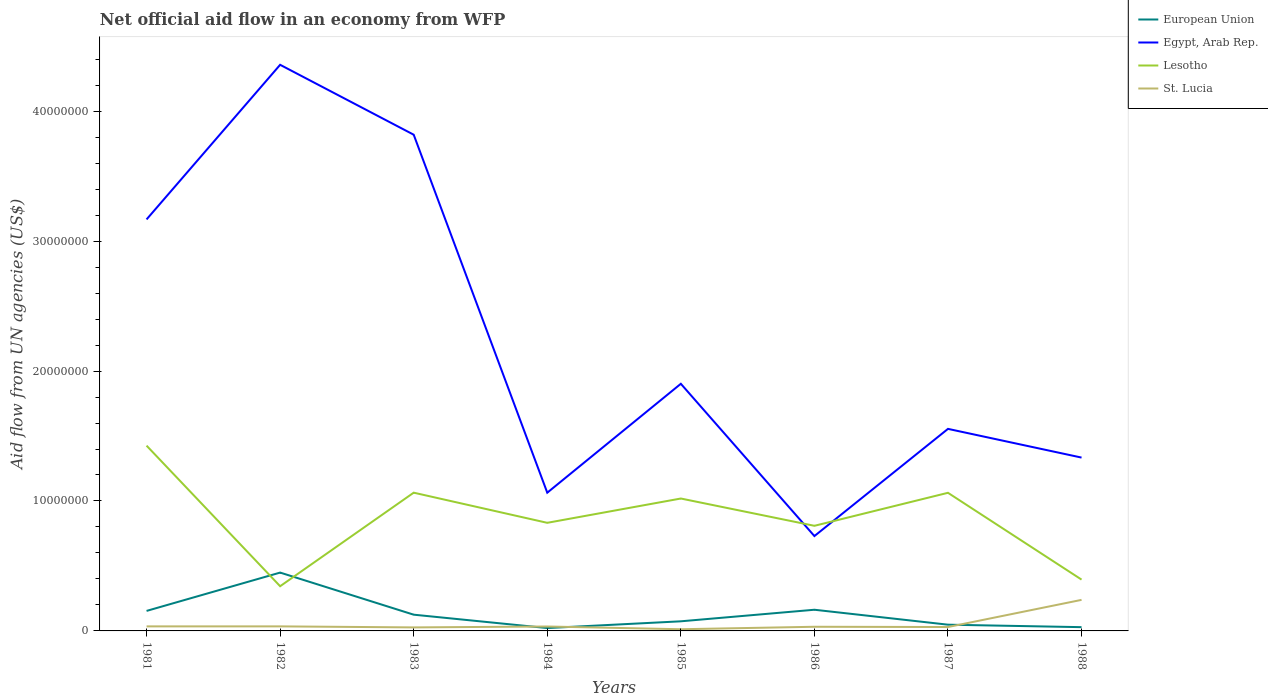How many different coloured lines are there?
Ensure brevity in your answer.  4. Is the number of lines equal to the number of legend labels?
Make the answer very short. Yes. In which year was the net official aid flow in Egypt, Arab Rep. maximum?
Your response must be concise. 1986. What is the total net official aid flow in European Union in the graph?
Give a very brief answer. -8.90e+05. What is the difference between the highest and the second highest net official aid flow in Lesotho?
Provide a short and direct response. 1.08e+07. How many lines are there?
Your response must be concise. 4. How many years are there in the graph?
Ensure brevity in your answer.  8. Are the values on the major ticks of Y-axis written in scientific E-notation?
Ensure brevity in your answer.  No. Does the graph contain any zero values?
Give a very brief answer. No. How many legend labels are there?
Keep it short and to the point. 4. How are the legend labels stacked?
Your response must be concise. Vertical. What is the title of the graph?
Your response must be concise. Net official aid flow in an economy from WFP. What is the label or title of the X-axis?
Provide a succinct answer. Years. What is the label or title of the Y-axis?
Your answer should be very brief. Aid flow from UN agencies (US$). What is the Aid flow from UN agencies (US$) of European Union in 1981?
Keep it short and to the point. 1.54e+06. What is the Aid flow from UN agencies (US$) of Egypt, Arab Rep. in 1981?
Your answer should be compact. 3.17e+07. What is the Aid flow from UN agencies (US$) in Lesotho in 1981?
Offer a terse response. 1.43e+07. What is the Aid flow from UN agencies (US$) of St. Lucia in 1981?
Keep it short and to the point. 3.50e+05. What is the Aid flow from UN agencies (US$) of European Union in 1982?
Your answer should be very brief. 4.49e+06. What is the Aid flow from UN agencies (US$) of Egypt, Arab Rep. in 1982?
Your response must be concise. 4.36e+07. What is the Aid flow from UN agencies (US$) of Lesotho in 1982?
Your answer should be compact. 3.44e+06. What is the Aid flow from UN agencies (US$) in St. Lucia in 1982?
Your response must be concise. 3.50e+05. What is the Aid flow from UN agencies (US$) of European Union in 1983?
Ensure brevity in your answer.  1.25e+06. What is the Aid flow from UN agencies (US$) in Egypt, Arab Rep. in 1983?
Ensure brevity in your answer.  3.82e+07. What is the Aid flow from UN agencies (US$) in Lesotho in 1983?
Your answer should be compact. 1.06e+07. What is the Aid flow from UN agencies (US$) in St. Lucia in 1983?
Give a very brief answer. 2.70e+05. What is the Aid flow from UN agencies (US$) of Egypt, Arab Rep. in 1984?
Provide a succinct answer. 1.06e+07. What is the Aid flow from UN agencies (US$) of Lesotho in 1984?
Keep it short and to the point. 8.32e+06. What is the Aid flow from UN agencies (US$) of St. Lucia in 1984?
Offer a very short reply. 3.40e+05. What is the Aid flow from UN agencies (US$) of European Union in 1985?
Your answer should be very brief. 7.40e+05. What is the Aid flow from UN agencies (US$) in Egypt, Arab Rep. in 1985?
Your response must be concise. 1.90e+07. What is the Aid flow from UN agencies (US$) of Lesotho in 1985?
Keep it short and to the point. 1.02e+07. What is the Aid flow from UN agencies (US$) of St. Lucia in 1985?
Provide a short and direct response. 1.30e+05. What is the Aid flow from UN agencies (US$) in European Union in 1986?
Provide a succinct answer. 1.63e+06. What is the Aid flow from UN agencies (US$) in Egypt, Arab Rep. in 1986?
Provide a short and direct response. 7.30e+06. What is the Aid flow from UN agencies (US$) of Lesotho in 1986?
Give a very brief answer. 8.09e+06. What is the Aid flow from UN agencies (US$) in Egypt, Arab Rep. in 1987?
Offer a terse response. 1.56e+07. What is the Aid flow from UN agencies (US$) of Lesotho in 1987?
Offer a very short reply. 1.06e+07. What is the Aid flow from UN agencies (US$) in European Union in 1988?
Your answer should be compact. 2.90e+05. What is the Aid flow from UN agencies (US$) in Egypt, Arab Rep. in 1988?
Offer a terse response. 1.33e+07. What is the Aid flow from UN agencies (US$) in Lesotho in 1988?
Provide a short and direct response. 3.95e+06. What is the Aid flow from UN agencies (US$) in St. Lucia in 1988?
Your response must be concise. 2.39e+06. Across all years, what is the maximum Aid flow from UN agencies (US$) in European Union?
Offer a very short reply. 4.49e+06. Across all years, what is the maximum Aid flow from UN agencies (US$) of Egypt, Arab Rep.?
Give a very brief answer. 4.36e+07. Across all years, what is the maximum Aid flow from UN agencies (US$) of Lesotho?
Provide a short and direct response. 1.43e+07. Across all years, what is the maximum Aid flow from UN agencies (US$) of St. Lucia?
Ensure brevity in your answer.  2.39e+06. Across all years, what is the minimum Aid flow from UN agencies (US$) in Egypt, Arab Rep.?
Your answer should be very brief. 7.30e+06. Across all years, what is the minimum Aid flow from UN agencies (US$) in Lesotho?
Your answer should be compact. 3.44e+06. Across all years, what is the minimum Aid flow from UN agencies (US$) in St. Lucia?
Provide a short and direct response. 1.30e+05. What is the total Aid flow from UN agencies (US$) of European Union in the graph?
Give a very brief answer. 1.06e+07. What is the total Aid flow from UN agencies (US$) in Egypt, Arab Rep. in the graph?
Make the answer very short. 1.79e+08. What is the total Aid flow from UN agencies (US$) of Lesotho in the graph?
Provide a short and direct response. 6.95e+07. What is the total Aid flow from UN agencies (US$) in St. Lucia in the graph?
Ensure brevity in your answer.  4.45e+06. What is the difference between the Aid flow from UN agencies (US$) in European Union in 1981 and that in 1982?
Offer a terse response. -2.95e+06. What is the difference between the Aid flow from UN agencies (US$) of Egypt, Arab Rep. in 1981 and that in 1982?
Make the answer very short. -1.19e+07. What is the difference between the Aid flow from UN agencies (US$) in Lesotho in 1981 and that in 1982?
Ensure brevity in your answer.  1.08e+07. What is the difference between the Aid flow from UN agencies (US$) of European Union in 1981 and that in 1983?
Your answer should be compact. 2.90e+05. What is the difference between the Aid flow from UN agencies (US$) of Egypt, Arab Rep. in 1981 and that in 1983?
Offer a terse response. -6.52e+06. What is the difference between the Aid flow from UN agencies (US$) of Lesotho in 1981 and that in 1983?
Your answer should be very brief. 3.62e+06. What is the difference between the Aid flow from UN agencies (US$) of European Union in 1981 and that in 1984?
Offer a terse response. 1.32e+06. What is the difference between the Aid flow from UN agencies (US$) in Egypt, Arab Rep. in 1981 and that in 1984?
Ensure brevity in your answer.  2.10e+07. What is the difference between the Aid flow from UN agencies (US$) in Lesotho in 1981 and that in 1984?
Ensure brevity in your answer.  5.94e+06. What is the difference between the Aid flow from UN agencies (US$) in European Union in 1981 and that in 1985?
Give a very brief answer. 8.00e+05. What is the difference between the Aid flow from UN agencies (US$) of Egypt, Arab Rep. in 1981 and that in 1985?
Keep it short and to the point. 1.26e+07. What is the difference between the Aid flow from UN agencies (US$) in Lesotho in 1981 and that in 1985?
Offer a very short reply. 4.07e+06. What is the difference between the Aid flow from UN agencies (US$) of St. Lucia in 1981 and that in 1985?
Ensure brevity in your answer.  2.20e+05. What is the difference between the Aid flow from UN agencies (US$) of Egypt, Arab Rep. in 1981 and that in 1986?
Keep it short and to the point. 2.44e+07. What is the difference between the Aid flow from UN agencies (US$) in Lesotho in 1981 and that in 1986?
Your answer should be compact. 6.17e+06. What is the difference between the Aid flow from UN agencies (US$) of St. Lucia in 1981 and that in 1986?
Your response must be concise. 3.00e+04. What is the difference between the Aid flow from UN agencies (US$) in European Union in 1981 and that in 1987?
Provide a succinct answer. 1.06e+06. What is the difference between the Aid flow from UN agencies (US$) of Egypt, Arab Rep. in 1981 and that in 1987?
Provide a short and direct response. 1.61e+07. What is the difference between the Aid flow from UN agencies (US$) in Lesotho in 1981 and that in 1987?
Your answer should be very brief. 3.63e+06. What is the difference between the Aid flow from UN agencies (US$) in St. Lucia in 1981 and that in 1987?
Your answer should be very brief. 5.00e+04. What is the difference between the Aid flow from UN agencies (US$) of European Union in 1981 and that in 1988?
Offer a terse response. 1.25e+06. What is the difference between the Aid flow from UN agencies (US$) in Egypt, Arab Rep. in 1981 and that in 1988?
Ensure brevity in your answer.  1.83e+07. What is the difference between the Aid flow from UN agencies (US$) in Lesotho in 1981 and that in 1988?
Offer a terse response. 1.03e+07. What is the difference between the Aid flow from UN agencies (US$) of St. Lucia in 1981 and that in 1988?
Offer a terse response. -2.04e+06. What is the difference between the Aid flow from UN agencies (US$) of European Union in 1982 and that in 1983?
Your answer should be very brief. 3.24e+06. What is the difference between the Aid flow from UN agencies (US$) of Egypt, Arab Rep. in 1982 and that in 1983?
Offer a very short reply. 5.38e+06. What is the difference between the Aid flow from UN agencies (US$) in Lesotho in 1982 and that in 1983?
Keep it short and to the point. -7.20e+06. What is the difference between the Aid flow from UN agencies (US$) of European Union in 1982 and that in 1984?
Your response must be concise. 4.27e+06. What is the difference between the Aid flow from UN agencies (US$) in Egypt, Arab Rep. in 1982 and that in 1984?
Your response must be concise. 3.29e+07. What is the difference between the Aid flow from UN agencies (US$) in Lesotho in 1982 and that in 1984?
Make the answer very short. -4.88e+06. What is the difference between the Aid flow from UN agencies (US$) in European Union in 1982 and that in 1985?
Give a very brief answer. 3.75e+06. What is the difference between the Aid flow from UN agencies (US$) in Egypt, Arab Rep. in 1982 and that in 1985?
Your answer should be very brief. 2.46e+07. What is the difference between the Aid flow from UN agencies (US$) of Lesotho in 1982 and that in 1985?
Your answer should be very brief. -6.75e+06. What is the difference between the Aid flow from UN agencies (US$) in European Union in 1982 and that in 1986?
Ensure brevity in your answer.  2.86e+06. What is the difference between the Aid flow from UN agencies (US$) of Egypt, Arab Rep. in 1982 and that in 1986?
Make the answer very short. 3.63e+07. What is the difference between the Aid flow from UN agencies (US$) of Lesotho in 1982 and that in 1986?
Ensure brevity in your answer.  -4.65e+06. What is the difference between the Aid flow from UN agencies (US$) in European Union in 1982 and that in 1987?
Make the answer very short. 4.01e+06. What is the difference between the Aid flow from UN agencies (US$) of Egypt, Arab Rep. in 1982 and that in 1987?
Give a very brief answer. 2.80e+07. What is the difference between the Aid flow from UN agencies (US$) in Lesotho in 1982 and that in 1987?
Give a very brief answer. -7.19e+06. What is the difference between the Aid flow from UN agencies (US$) in European Union in 1982 and that in 1988?
Offer a terse response. 4.20e+06. What is the difference between the Aid flow from UN agencies (US$) in Egypt, Arab Rep. in 1982 and that in 1988?
Provide a succinct answer. 3.02e+07. What is the difference between the Aid flow from UN agencies (US$) of Lesotho in 1982 and that in 1988?
Offer a terse response. -5.10e+05. What is the difference between the Aid flow from UN agencies (US$) of St. Lucia in 1982 and that in 1988?
Make the answer very short. -2.04e+06. What is the difference between the Aid flow from UN agencies (US$) in European Union in 1983 and that in 1984?
Ensure brevity in your answer.  1.03e+06. What is the difference between the Aid flow from UN agencies (US$) in Egypt, Arab Rep. in 1983 and that in 1984?
Ensure brevity in your answer.  2.76e+07. What is the difference between the Aid flow from UN agencies (US$) in Lesotho in 1983 and that in 1984?
Your answer should be very brief. 2.32e+06. What is the difference between the Aid flow from UN agencies (US$) of St. Lucia in 1983 and that in 1984?
Make the answer very short. -7.00e+04. What is the difference between the Aid flow from UN agencies (US$) of European Union in 1983 and that in 1985?
Provide a succinct answer. 5.10e+05. What is the difference between the Aid flow from UN agencies (US$) of Egypt, Arab Rep. in 1983 and that in 1985?
Provide a short and direct response. 1.92e+07. What is the difference between the Aid flow from UN agencies (US$) of European Union in 1983 and that in 1986?
Provide a succinct answer. -3.80e+05. What is the difference between the Aid flow from UN agencies (US$) of Egypt, Arab Rep. in 1983 and that in 1986?
Your answer should be very brief. 3.09e+07. What is the difference between the Aid flow from UN agencies (US$) of Lesotho in 1983 and that in 1986?
Provide a succinct answer. 2.55e+06. What is the difference between the Aid flow from UN agencies (US$) of St. Lucia in 1983 and that in 1986?
Make the answer very short. -5.00e+04. What is the difference between the Aid flow from UN agencies (US$) in European Union in 1983 and that in 1987?
Make the answer very short. 7.70e+05. What is the difference between the Aid flow from UN agencies (US$) of Egypt, Arab Rep. in 1983 and that in 1987?
Your answer should be very brief. 2.26e+07. What is the difference between the Aid flow from UN agencies (US$) in Lesotho in 1983 and that in 1987?
Your answer should be compact. 10000. What is the difference between the Aid flow from UN agencies (US$) in St. Lucia in 1983 and that in 1987?
Your answer should be compact. -3.00e+04. What is the difference between the Aid flow from UN agencies (US$) in European Union in 1983 and that in 1988?
Your answer should be very brief. 9.60e+05. What is the difference between the Aid flow from UN agencies (US$) of Egypt, Arab Rep. in 1983 and that in 1988?
Your answer should be compact. 2.48e+07. What is the difference between the Aid flow from UN agencies (US$) in Lesotho in 1983 and that in 1988?
Offer a very short reply. 6.69e+06. What is the difference between the Aid flow from UN agencies (US$) in St. Lucia in 1983 and that in 1988?
Offer a very short reply. -2.12e+06. What is the difference between the Aid flow from UN agencies (US$) of European Union in 1984 and that in 1985?
Your answer should be very brief. -5.20e+05. What is the difference between the Aid flow from UN agencies (US$) in Egypt, Arab Rep. in 1984 and that in 1985?
Provide a short and direct response. -8.38e+06. What is the difference between the Aid flow from UN agencies (US$) in Lesotho in 1984 and that in 1985?
Give a very brief answer. -1.87e+06. What is the difference between the Aid flow from UN agencies (US$) in European Union in 1984 and that in 1986?
Give a very brief answer. -1.41e+06. What is the difference between the Aid flow from UN agencies (US$) in Egypt, Arab Rep. in 1984 and that in 1986?
Your answer should be very brief. 3.34e+06. What is the difference between the Aid flow from UN agencies (US$) in European Union in 1984 and that in 1987?
Your answer should be very brief. -2.60e+05. What is the difference between the Aid flow from UN agencies (US$) of Egypt, Arab Rep. in 1984 and that in 1987?
Your response must be concise. -4.91e+06. What is the difference between the Aid flow from UN agencies (US$) of Lesotho in 1984 and that in 1987?
Provide a succinct answer. -2.31e+06. What is the difference between the Aid flow from UN agencies (US$) in St. Lucia in 1984 and that in 1987?
Your answer should be compact. 4.00e+04. What is the difference between the Aid flow from UN agencies (US$) in European Union in 1984 and that in 1988?
Provide a succinct answer. -7.00e+04. What is the difference between the Aid flow from UN agencies (US$) of Egypt, Arab Rep. in 1984 and that in 1988?
Your answer should be compact. -2.70e+06. What is the difference between the Aid flow from UN agencies (US$) of Lesotho in 1984 and that in 1988?
Ensure brevity in your answer.  4.37e+06. What is the difference between the Aid flow from UN agencies (US$) in St. Lucia in 1984 and that in 1988?
Ensure brevity in your answer.  -2.05e+06. What is the difference between the Aid flow from UN agencies (US$) in European Union in 1985 and that in 1986?
Ensure brevity in your answer.  -8.90e+05. What is the difference between the Aid flow from UN agencies (US$) in Egypt, Arab Rep. in 1985 and that in 1986?
Keep it short and to the point. 1.17e+07. What is the difference between the Aid flow from UN agencies (US$) of Lesotho in 1985 and that in 1986?
Provide a short and direct response. 2.10e+06. What is the difference between the Aid flow from UN agencies (US$) in St. Lucia in 1985 and that in 1986?
Provide a short and direct response. -1.90e+05. What is the difference between the Aid flow from UN agencies (US$) in European Union in 1985 and that in 1987?
Your answer should be compact. 2.60e+05. What is the difference between the Aid flow from UN agencies (US$) in Egypt, Arab Rep. in 1985 and that in 1987?
Your response must be concise. 3.47e+06. What is the difference between the Aid flow from UN agencies (US$) of Lesotho in 1985 and that in 1987?
Ensure brevity in your answer.  -4.40e+05. What is the difference between the Aid flow from UN agencies (US$) of St. Lucia in 1985 and that in 1987?
Make the answer very short. -1.70e+05. What is the difference between the Aid flow from UN agencies (US$) in European Union in 1985 and that in 1988?
Offer a terse response. 4.50e+05. What is the difference between the Aid flow from UN agencies (US$) of Egypt, Arab Rep. in 1985 and that in 1988?
Provide a short and direct response. 5.68e+06. What is the difference between the Aid flow from UN agencies (US$) in Lesotho in 1985 and that in 1988?
Make the answer very short. 6.24e+06. What is the difference between the Aid flow from UN agencies (US$) of St. Lucia in 1985 and that in 1988?
Ensure brevity in your answer.  -2.26e+06. What is the difference between the Aid flow from UN agencies (US$) in European Union in 1986 and that in 1987?
Offer a very short reply. 1.15e+06. What is the difference between the Aid flow from UN agencies (US$) of Egypt, Arab Rep. in 1986 and that in 1987?
Offer a very short reply. -8.25e+06. What is the difference between the Aid flow from UN agencies (US$) in Lesotho in 1986 and that in 1987?
Provide a short and direct response. -2.54e+06. What is the difference between the Aid flow from UN agencies (US$) in St. Lucia in 1986 and that in 1987?
Make the answer very short. 2.00e+04. What is the difference between the Aid flow from UN agencies (US$) of European Union in 1986 and that in 1988?
Your answer should be very brief. 1.34e+06. What is the difference between the Aid flow from UN agencies (US$) of Egypt, Arab Rep. in 1986 and that in 1988?
Give a very brief answer. -6.04e+06. What is the difference between the Aid flow from UN agencies (US$) in Lesotho in 1986 and that in 1988?
Provide a short and direct response. 4.14e+06. What is the difference between the Aid flow from UN agencies (US$) in St. Lucia in 1986 and that in 1988?
Provide a short and direct response. -2.07e+06. What is the difference between the Aid flow from UN agencies (US$) of Egypt, Arab Rep. in 1987 and that in 1988?
Provide a short and direct response. 2.21e+06. What is the difference between the Aid flow from UN agencies (US$) in Lesotho in 1987 and that in 1988?
Ensure brevity in your answer.  6.68e+06. What is the difference between the Aid flow from UN agencies (US$) in St. Lucia in 1987 and that in 1988?
Keep it short and to the point. -2.09e+06. What is the difference between the Aid flow from UN agencies (US$) in European Union in 1981 and the Aid flow from UN agencies (US$) in Egypt, Arab Rep. in 1982?
Offer a terse response. -4.20e+07. What is the difference between the Aid flow from UN agencies (US$) of European Union in 1981 and the Aid flow from UN agencies (US$) of Lesotho in 1982?
Offer a very short reply. -1.90e+06. What is the difference between the Aid flow from UN agencies (US$) of European Union in 1981 and the Aid flow from UN agencies (US$) of St. Lucia in 1982?
Offer a terse response. 1.19e+06. What is the difference between the Aid flow from UN agencies (US$) in Egypt, Arab Rep. in 1981 and the Aid flow from UN agencies (US$) in Lesotho in 1982?
Provide a succinct answer. 2.82e+07. What is the difference between the Aid flow from UN agencies (US$) in Egypt, Arab Rep. in 1981 and the Aid flow from UN agencies (US$) in St. Lucia in 1982?
Make the answer very short. 3.13e+07. What is the difference between the Aid flow from UN agencies (US$) in Lesotho in 1981 and the Aid flow from UN agencies (US$) in St. Lucia in 1982?
Your answer should be compact. 1.39e+07. What is the difference between the Aid flow from UN agencies (US$) of European Union in 1981 and the Aid flow from UN agencies (US$) of Egypt, Arab Rep. in 1983?
Keep it short and to the point. -3.66e+07. What is the difference between the Aid flow from UN agencies (US$) of European Union in 1981 and the Aid flow from UN agencies (US$) of Lesotho in 1983?
Give a very brief answer. -9.10e+06. What is the difference between the Aid flow from UN agencies (US$) in European Union in 1981 and the Aid flow from UN agencies (US$) in St. Lucia in 1983?
Provide a short and direct response. 1.27e+06. What is the difference between the Aid flow from UN agencies (US$) in Egypt, Arab Rep. in 1981 and the Aid flow from UN agencies (US$) in Lesotho in 1983?
Your answer should be very brief. 2.10e+07. What is the difference between the Aid flow from UN agencies (US$) of Egypt, Arab Rep. in 1981 and the Aid flow from UN agencies (US$) of St. Lucia in 1983?
Make the answer very short. 3.14e+07. What is the difference between the Aid flow from UN agencies (US$) of Lesotho in 1981 and the Aid flow from UN agencies (US$) of St. Lucia in 1983?
Ensure brevity in your answer.  1.40e+07. What is the difference between the Aid flow from UN agencies (US$) of European Union in 1981 and the Aid flow from UN agencies (US$) of Egypt, Arab Rep. in 1984?
Make the answer very short. -9.10e+06. What is the difference between the Aid flow from UN agencies (US$) of European Union in 1981 and the Aid flow from UN agencies (US$) of Lesotho in 1984?
Your response must be concise. -6.78e+06. What is the difference between the Aid flow from UN agencies (US$) in European Union in 1981 and the Aid flow from UN agencies (US$) in St. Lucia in 1984?
Provide a short and direct response. 1.20e+06. What is the difference between the Aid flow from UN agencies (US$) in Egypt, Arab Rep. in 1981 and the Aid flow from UN agencies (US$) in Lesotho in 1984?
Make the answer very short. 2.34e+07. What is the difference between the Aid flow from UN agencies (US$) of Egypt, Arab Rep. in 1981 and the Aid flow from UN agencies (US$) of St. Lucia in 1984?
Make the answer very short. 3.13e+07. What is the difference between the Aid flow from UN agencies (US$) of Lesotho in 1981 and the Aid flow from UN agencies (US$) of St. Lucia in 1984?
Your answer should be very brief. 1.39e+07. What is the difference between the Aid flow from UN agencies (US$) in European Union in 1981 and the Aid flow from UN agencies (US$) in Egypt, Arab Rep. in 1985?
Your answer should be very brief. -1.75e+07. What is the difference between the Aid flow from UN agencies (US$) of European Union in 1981 and the Aid flow from UN agencies (US$) of Lesotho in 1985?
Your answer should be compact. -8.65e+06. What is the difference between the Aid flow from UN agencies (US$) in European Union in 1981 and the Aid flow from UN agencies (US$) in St. Lucia in 1985?
Offer a terse response. 1.41e+06. What is the difference between the Aid flow from UN agencies (US$) in Egypt, Arab Rep. in 1981 and the Aid flow from UN agencies (US$) in Lesotho in 1985?
Make the answer very short. 2.15e+07. What is the difference between the Aid flow from UN agencies (US$) of Egypt, Arab Rep. in 1981 and the Aid flow from UN agencies (US$) of St. Lucia in 1985?
Give a very brief answer. 3.15e+07. What is the difference between the Aid flow from UN agencies (US$) in Lesotho in 1981 and the Aid flow from UN agencies (US$) in St. Lucia in 1985?
Give a very brief answer. 1.41e+07. What is the difference between the Aid flow from UN agencies (US$) in European Union in 1981 and the Aid flow from UN agencies (US$) in Egypt, Arab Rep. in 1986?
Ensure brevity in your answer.  -5.76e+06. What is the difference between the Aid flow from UN agencies (US$) in European Union in 1981 and the Aid flow from UN agencies (US$) in Lesotho in 1986?
Ensure brevity in your answer.  -6.55e+06. What is the difference between the Aid flow from UN agencies (US$) in European Union in 1981 and the Aid flow from UN agencies (US$) in St. Lucia in 1986?
Provide a succinct answer. 1.22e+06. What is the difference between the Aid flow from UN agencies (US$) in Egypt, Arab Rep. in 1981 and the Aid flow from UN agencies (US$) in Lesotho in 1986?
Ensure brevity in your answer.  2.36e+07. What is the difference between the Aid flow from UN agencies (US$) of Egypt, Arab Rep. in 1981 and the Aid flow from UN agencies (US$) of St. Lucia in 1986?
Offer a very short reply. 3.14e+07. What is the difference between the Aid flow from UN agencies (US$) in Lesotho in 1981 and the Aid flow from UN agencies (US$) in St. Lucia in 1986?
Your response must be concise. 1.39e+07. What is the difference between the Aid flow from UN agencies (US$) in European Union in 1981 and the Aid flow from UN agencies (US$) in Egypt, Arab Rep. in 1987?
Give a very brief answer. -1.40e+07. What is the difference between the Aid flow from UN agencies (US$) of European Union in 1981 and the Aid flow from UN agencies (US$) of Lesotho in 1987?
Your answer should be compact. -9.09e+06. What is the difference between the Aid flow from UN agencies (US$) in European Union in 1981 and the Aid flow from UN agencies (US$) in St. Lucia in 1987?
Give a very brief answer. 1.24e+06. What is the difference between the Aid flow from UN agencies (US$) in Egypt, Arab Rep. in 1981 and the Aid flow from UN agencies (US$) in Lesotho in 1987?
Offer a very short reply. 2.10e+07. What is the difference between the Aid flow from UN agencies (US$) in Egypt, Arab Rep. in 1981 and the Aid flow from UN agencies (US$) in St. Lucia in 1987?
Give a very brief answer. 3.14e+07. What is the difference between the Aid flow from UN agencies (US$) in Lesotho in 1981 and the Aid flow from UN agencies (US$) in St. Lucia in 1987?
Ensure brevity in your answer.  1.40e+07. What is the difference between the Aid flow from UN agencies (US$) in European Union in 1981 and the Aid flow from UN agencies (US$) in Egypt, Arab Rep. in 1988?
Keep it short and to the point. -1.18e+07. What is the difference between the Aid flow from UN agencies (US$) in European Union in 1981 and the Aid flow from UN agencies (US$) in Lesotho in 1988?
Your answer should be very brief. -2.41e+06. What is the difference between the Aid flow from UN agencies (US$) of European Union in 1981 and the Aid flow from UN agencies (US$) of St. Lucia in 1988?
Your response must be concise. -8.50e+05. What is the difference between the Aid flow from UN agencies (US$) of Egypt, Arab Rep. in 1981 and the Aid flow from UN agencies (US$) of Lesotho in 1988?
Provide a succinct answer. 2.77e+07. What is the difference between the Aid flow from UN agencies (US$) in Egypt, Arab Rep. in 1981 and the Aid flow from UN agencies (US$) in St. Lucia in 1988?
Offer a terse response. 2.93e+07. What is the difference between the Aid flow from UN agencies (US$) of Lesotho in 1981 and the Aid flow from UN agencies (US$) of St. Lucia in 1988?
Offer a very short reply. 1.19e+07. What is the difference between the Aid flow from UN agencies (US$) in European Union in 1982 and the Aid flow from UN agencies (US$) in Egypt, Arab Rep. in 1983?
Make the answer very short. -3.37e+07. What is the difference between the Aid flow from UN agencies (US$) of European Union in 1982 and the Aid flow from UN agencies (US$) of Lesotho in 1983?
Your answer should be compact. -6.15e+06. What is the difference between the Aid flow from UN agencies (US$) of European Union in 1982 and the Aid flow from UN agencies (US$) of St. Lucia in 1983?
Your answer should be compact. 4.22e+06. What is the difference between the Aid flow from UN agencies (US$) of Egypt, Arab Rep. in 1982 and the Aid flow from UN agencies (US$) of Lesotho in 1983?
Give a very brief answer. 3.29e+07. What is the difference between the Aid flow from UN agencies (US$) in Egypt, Arab Rep. in 1982 and the Aid flow from UN agencies (US$) in St. Lucia in 1983?
Make the answer very short. 4.33e+07. What is the difference between the Aid flow from UN agencies (US$) of Lesotho in 1982 and the Aid flow from UN agencies (US$) of St. Lucia in 1983?
Offer a terse response. 3.17e+06. What is the difference between the Aid flow from UN agencies (US$) of European Union in 1982 and the Aid flow from UN agencies (US$) of Egypt, Arab Rep. in 1984?
Your answer should be compact. -6.15e+06. What is the difference between the Aid flow from UN agencies (US$) in European Union in 1982 and the Aid flow from UN agencies (US$) in Lesotho in 1984?
Give a very brief answer. -3.83e+06. What is the difference between the Aid flow from UN agencies (US$) in European Union in 1982 and the Aid flow from UN agencies (US$) in St. Lucia in 1984?
Offer a very short reply. 4.15e+06. What is the difference between the Aid flow from UN agencies (US$) of Egypt, Arab Rep. in 1982 and the Aid flow from UN agencies (US$) of Lesotho in 1984?
Provide a short and direct response. 3.52e+07. What is the difference between the Aid flow from UN agencies (US$) of Egypt, Arab Rep. in 1982 and the Aid flow from UN agencies (US$) of St. Lucia in 1984?
Offer a terse response. 4.32e+07. What is the difference between the Aid flow from UN agencies (US$) of Lesotho in 1982 and the Aid flow from UN agencies (US$) of St. Lucia in 1984?
Provide a short and direct response. 3.10e+06. What is the difference between the Aid flow from UN agencies (US$) of European Union in 1982 and the Aid flow from UN agencies (US$) of Egypt, Arab Rep. in 1985?
Offer a very short reply. -1.45e+07. What is the difference between the Aid flow from UN agencies (US$) in European Union in 1982 and the Aid flow from UN agencies (US$) in Lesotho in 1985?
Offer a terse response. -5.70e+06. What is the difference between the Aid flow from UN agencies (US$) in European Union in 1982 and the Aid flow from UN agencies (US$) in St. Lucia in 1985?
Make the answer very short. 4.36e+06. What is the difference between the Aid flow from UN agencies (US$) in Egypt, Arab Rep. in 1982 and the Aid flow from UN agencies (US$) in Lesotho in 1985?
Your answer should be compact. 3.34e+07. What is the difference between the Aid flow from UN agencies (US$) of Egypt, Arab Rep. in 1982 and the Aid flow from UN agencies (US$) of St. Lucia in 1985?
Your answer should be compact. 4.34e+07. What is the difference between the Aid flow from UN agencies (US$) of Lesotho in 1982 and the Aid flow from UN agencies (US$) of St. Lucia in 1985?
Provide a succinct answer. 3.31e+06. What is the difference between the Aid flow from UN agencies (US$) in European Union in 1982 and the Aid flow from UN agencies (US$) in Egypt, Arab Rep. in 1986?
Keep it short and to the point. -2.81e+06. What is the difference between the Aid flow from UN agencies (US$) in European Union in 1982 and the Aid flow from UN agencies (US$) in Lesotho in 1986?
Provide a succinct answer. -3.60e+06. What is the difference between the Aid flow from UN agencies (US$) in European Union in 1982 and the Aid flow from UN agencies (US$) in St. Lucia in 1986?
Keep it short and to the point. 4.17e+06. What is the difference between the Aid flow from UN agencies (US$) in Egypt, Arab Rep. in 1982 and the Aid flow from UN agencies (US$) in Lesotho in 1986?
Ensure brevity in your answer.  3.55e+07. What is the difference between the Aid flow from UN agencies (US$) in Egypt, Arab Rep. in 1982 and the Aid flow from UN agencies (US$) in St. Lucia in 1986?
Your answer should be compact. 4.32e+07. What is the difference between the Aid flow from UN agencies (US$) in Lesotho in 1982 and the Aid flow from UN agencies (US$) in St. Lucia in 1986?
Give a very brief answer. 3.12e+06. What is the difference between the Aid flow from UN agencies (US$) in European Union in 1982 and the Aid flow from UN agencies (US$) in Egypt, Arab Rep. in 1987?
Offer a very short reply. -1.11e+07. What is the difference between the Aid flow from UN agencies (US$) in European Union in 1982 and the Aid flow from UN agencies (US$) in Lesotho in 1987?
Your response must be concise. -6.14e+06. What is the difference between the Aid flow from UN agencies (US$) in European Union in 1982 and the Aid flow from UN agencies (US$) in St. Lucia in 1987?
Your response must be concise. 4.19e+06. What is the difference between the Aid flow from UN agencies (US$) in Egypt, Arab Rep. in 1982 and the Aid flow from UN agencies (US$) in Lesotho in 1987?
Provide a succinct answer. 3.29e+07. What is the difference between the Aid flow from UN agencies (US$) in Egypt, Arab Rep. in 1982 and the Aid flow from UN agencies (US$) in St. Lucia in 1987?
Your response must be concise. 4.33e+07. What is the difference between the Aid flow from UN agencies (US$) of Lesotho in 1982 and the Aid flow from UN agencies (US$) of St. Lucia in 1987?
Offer a terse response. 3.14e+06. What is the difference between the Aid flow from UN agencies (US$) in European Union in 1982 and the Aid flow from UN agencies (US$) in Egypt, Arab Rep. in 1988?
Ensure brevity in your answer.  -8.85e+06. What is the difference between the Aid flow from UN agencies (US$) of European Union in 1982 and the Aid flow from UN agencies (US$) of Lesotho in 1988?
Give a very brief answer. 5.40e+05. What is the difference between the Aid flow from UN agencies (US$) of European Union in 1982 and the Aid flow from UN agencies (US$) of St. Lucia in 1988?
Offer a terse response. 2.10e+06. What is the difference between the Aid flow from UN agencies (US$) in Egypt, Arab Rep. in 1982 and the Aid flow from UN agencies (US$) in Lesotho in 1988?
Provide a short and direct response. 3.96e+07. What is the difference between the Aid flow from UN agencies (US$) in Egypt, Arab Rep. in 1982 and the Aid flow from UN agencies (US$) in St. Lucia in 1988?
Ensure brevity in your answer.  4.12e+07. What is the difference between the Aid flow from UN agencies (US$) in Lesotho in 1982 and the Aid flow from UN agencies (US$) in St. Lucia in 1988?
Offer a terse response. 1.05e+06. What is the difference between the Aid flow from UN agencies (US$) of European Union in 1983 and the Aid flow from UN agencies (US$) of Egypt, Arab Rep. in 1984?
Your answer should be very brief. -9.39e+06. What is the difference between the Aid flow from UN agencies (US$) in European Union in 1983 and the Aid flow from UN agencies (US$) in Lesotho in 1984?
Give a very brief answer. -7.07e+06. What is the difference between the Aid flow from UN agencies (US$) in European Union in 1983 and the Aid flow from UN agencies (US$) in St. Lucia in 1984?
Provide a succinct answer. 9.10e+05. What is the difference between the Aid flow from UN agencies (US$) in Egypt, Arab Rep. in 1983 and the Aid flow from UN agencies (US$) in Lesotho in 1984?
Give a very brief answer. 2.99e+07. What is the difference between the Aid flow from UN agencies (US$) of Egypt, Arab Rep. in 1983 and the Aid flow from UN agencies (US$) of St. Lucia in 1984?
Your response must be concise. 3.78e+07. What is the difference between the Aid flow from UN agencies (US$) of Lesotho in 1983 and the Aid flow from UN agencies (US$) of St. Lucia in 1984?
Provide a succinct answer. 1.03e+07. What is the difference between the Aid flow from UN agencies (US$) in European Union in 1983 and the Aid flow from UN agencies (US$) in Egypt, Arab Rep. in 1985?
Your response must be concise. -1.78e+07. What is the difference between the Aid flow from UN agencies (US$) of European Union in 1983 and the Aid flow from UN agencies (US$) of Lesotho in 1985?
Your answer should be compact. -8.94e+06. What is the difference between the Aid flow from UN agencies (US$) of European Union in 1983 and the Aid flow from UN agencies (US$) of St. Lucia in 1985?
Your answer should be compact. 1.12e+06. What is the difference between the Aid flow from UN agencies (US$) in Egypt, Arab Rep. in 1983 and the Aid flow from UN agencies (US$) in Lesotho in 1985?
Offer a terse response. 2.80e+07. What is the difference between the Aid flow from UN agencies (US$) of Egypt, Arab Rep. in 1983 and the Aid flow from UN agencies (US$) of St. Lucia in 1985?
Give a very brief answer. 3.81e+07. What is the difference between the Aid flow from UN agencies (US$) in Lesotho in 1983 and the Aid flow from UN agencies (US$) in St. Lucia in 1985?
Ensure brevity in your answer.  1.05e+07. What is the difference between the Aid flow from UN agencies (US$) of European Union in 1983 and the Aid flow from UN agencies (US$) of Egypt, Arab Rep. in 1986?
Your answer should be compact. -6.05e+06. What is the difference between the Aid flow from UN agencies (US$) of European Union in 1983 and the Aid flow from UN agencies (US$) of Lesotho in 1986?
Your response must be concise. -6.84e+06. What is the difference between the Aid flow from UN agencies (US$) in European Union in 1983 and the Aid flow from UN agencies (US$) in St. Lucia in 1986?
Your answer should be compact. 9.30e+05. What is the difference between the Aid flow from UN agencies (US$) in Egypt, Arab Rep. in 1983 and the Aid flow from UN agencies (US$) in Lesotho in 1986?
Provide a succinct answer. 3.01e+07. What is the difference between the Aid flow from UN agencies (US$) in Egypt, Arab Rep. in 1983 and the Aid flow from UN agencies (US$) in St. Lucia in 1986?
Give a very brief answer. 3.79e+07. What is the difference between the Aid flow from UN agencies (US$) in Lesotho in 1983 and the Aid flow from UN agencies (US$) in St. Lucia in 1986?
Keep it short and to the point. 1.03e+07. What is the difference between the Aid flow from UN agencies (US$) in European Union in 1983 and the Aid flow from UN agencies (US$) in Egypt, Arab Rep. in 1987?
Provide a short and direct response. -1.43e+07. What is the difference between the Aid flow from UN agencies (US$) of European Union in 1983 and the Aid flow from UN agencies (US$) of Lesotho in 1987?
Give a very brief answer. -9.38e+06. What is the difference between the Aid flow from UN agencies (US$) in European Union in 1983 and the Aid flow from UN agencies (US$) in St. Lucia in 1987?
Offer a very short reply. 9.50e+05. What is the difference between the Aid flow from UN agencies (US$) of Egypt, Arab Rep. in 1983 and the Aid flow from UN agencies (US$) of Lesotho in 1987?
Make the answer very short. 2.76e+07. What is the difference between the Aid flow from UN agencies (US$) in Egypt, Arab Rep. in 1983 and the Aid flow from UN agencies (US$) in St. Lucia in 1987?
Make the answer very short. 3.79e+07. What is the difference between the Aid flow from UN agencies (US$) in Lesotho in 1983 and the Aid flow from UN agencies (US$) in St. Lucia in 1987?
Your response must be concise. 1.03e+07. What is the difference between the Aid flow from UN agencies (US$) in European Union in 1983 and the Aid flow from UN agencies (US$) in Egypt, Arab Rep. in 1988?
Make the answer very short. -1.21e+07. What is the difference between the Aid flow from UN agencies (US$) in European Union in 1983 and the Aid flow from UN agencies (US$) in Lesotho in 1988?
Ensure brevity in your answer.  -2.70e+06. What is the difference between the Aid flow from UN agencies (US$) in European Union in 1983 and the Aid flow from UN agencies (US$) in St. Lucia in 1988?
Provide a short and direct response. -1.14e+06. What is the difference between the Aid flow from UN agencies (US$) of Egypt, Arab Rep. in 1983 and the Aid flow from UN agencies (US$) of Lesotho in 1988?
Offer a terse response. 3.42e+07. What is the difference between the Aid flow from UN agencies (US$) in Egypt, Arab Rep. in 1983 and the Aid flow from UN agencies (US$) in St. Lucia in 1988?
Offer a terse response. 3.58e+07. What is the difference between the Aid flow from UN agencies (US$) in Lesotho in 1983 and the Aid flow from UN agencies (US$) in St. Lucia in 1988?
Make the answer very short. 8.25e+06. What is the difference between the Aid flow from UN agencies (US$) of European Union in 1984 and the Aid flow from UN agencies (US$) of Egypt, Arab Rep. in 1985?
Provide a succinct answer. -1.88e+07. What is the difference between the Aid flow from UN agencies (US$) in European Union in 1984 and the Aid flow from UN agencies (US$) in Lesotho in 1985?
Make the answer very short. -9.97e+06. What is the difference between the Aid flow from UN agencies (US$) of Egypt, Arab Rep. in 1984 and the Aid flow from UN agencies (US$) of St. Lucia in 1985?
Provide a succinct answer. 1.05e+07. What is the difference between the Aid flow from UN agencies (US$) of Lesotho in 1984 and the Aid flow from UN agencies (US$) of St. Lucia in 1985?
Make the answer very short. 8.19e+06. What is the difference between the Aid flow from UN agencies (US$) of European Union in 1984 and the Aid flow from UN agencies (US$) of Egypt, Arab Rep. in 1986?
Provide a succinct answer. -7.08e+06. What is the difference between the Aid flow from UN agencies (US$) in European Union in 1984 and the Aid flow from UN agencies (US$) in Lesotho in 1986?
Give a very brief answer. -7.87e+06. What is the difference between the Aid flow from UN agencies (US$) in Egypt, Arab Rep. in 1984 and the Aid flow from UN agencies (US$) in Lesotho in 1986?
Keep it short and to the point. 2.55e+06. What is the difference between the Aid flow from UN agencies (US$) in Egypt, Arab Rep. in 1984 and the Aid flow from UN agencies (US$) in St. Lucia in 1986?
Offer a terse response. 1.03e+07. What is the difference between the Aid flow from UN agencies (US$) in Lesotho in 1984 and the Aid flow from UN agencies (US$) in St. Lucia in 1986?
Provide a short and direct response. 8.00e+06. What is the difference between the Aid flow from UN agencies (US$) in European Union in 1984 and the Aid flow from UN agencies (US$) in Egypt, Arab Rep. in 1987?
Keep it short and to the point. -1.53e+07. What is the difference between the Aid flow from UN agencies (US$) in European Union in 1984 and the Aid flow from UN agencies (US$) in Lesotho in 1987?
Offer a terse response. -1.04e+07. What is the difference between the Aid flow from UN agencies (US$) of Egypt, Arab Rep. in 1984 and the Aid flow from UN agencies (US$) of Lesotho in 1987?
Keep it short and to the point. 10000. What is the difference between the Aid flow from UN agencies (US$) of Egypt, Arab Rep. in 1984 and the Aid flow from UN agencies (US$) of St. Lucia in 1987?
Offer a very short reply. 1.03e+07. What is the difference between the Aid flow from UN agencies (US$) of Lesotho in 1984 and the Aid flow from UN agencies (US$) of St. Lucia in 1987?
Your response must be concise. 8.02e+06. What is the difference between the Aid flow from UN agencies (US$) of European Union in 1984 and the Aid flow from UN agencies (US$) of Egypt, Arab Rep. in 1988?
Your answer should be very brief. -1.31e+07. What is the difference between the Aid flow from UN agencies (US$) of European Union in 1984 and the Aid flow from UN agencies (US$) of Lesotho in 1988?
Provide a succinct answer. -3.73e+06. What is the difference between the Aid flow from UN agencies (US$) of European Union in 1984 and the Aid flow from UN agencies (US$) of St. Lucia in 1988?
Provide a succinct answer. -2.17e+06. What is the difference between the Aid flow from UN agencies (US$) of Egypt, Arab Rep. in 1984 and the Aid flow from UN agencies (US$) of Lesotho in 1988?
Your answer should be compact. 6.69e+06. What is the difference between the Aid flow from UN agencies (US$) in Egypt, Arab Rep. in 1984 and the Aid flow from UN agencies (US$) in St. Lucia in 1988?
Offer a terse response. 8.25e+06. What is the difference between the Aid flow from UN agencies (US$) in Lesotho in 1984 and the Aid flow from UN agencies (US$) in St. Lucia in 1988?
Offer a very short reply. 5.93e+06. What is the difference between the Aid flow from UN agencies (US$) in European Union in 1985 and the Aid flow from UN agencies (US$) in Egypt, Arab Rep. in 1986?
Provide a succinct answer. -6.56e+06. What is the difference between the Aid flow from UN agencies (US$) of European Union in 1985 and the Aid flow from UN agencies (US$) of Lesotho in 1986?
Ensure brevity in your answer.  -7.35e+06. What is the difference between the Aid flow from UN agencies (US$) in Egypt, Arab Rep. in 1985 and the Aid flow from UN agencies (US$) in Lesotho in 1986?
Ensure brevity in your answer.  1.09e+07. What is the difference between the Aid flow from UN agencies (US$) in Egypt, Arab Rep. in 1985 and the Aid flow from UN agencies (US$) in St. Lucia in 1986?
Your answer should be very brief. 1.87e+07. What is the difference between the Aid flow from UN agencies (US$) in Lesotho in 1985 and the Aid flow from UN agencies (US$) in St. Lucia in 1986?
Provide a short and direct response. 9.87e+06. What is the difference between the Aid flow from UN agencies (US$) in European Union in 1985 and the Aid flow from UN agencies (US$) in Egypt, Arab Rep. in 1987?
Give a very brief answer. -1.48e+07. What is the difference between the Aid flow from UN agencies (US$) in European Union in 1985 and the Aid flow from UN agencies (US$) in Lesotho in 1987?
Offer a terse response. -9.89e+06. What is the difference between the Aid flow from UN agencies (US$) in European Union in 1985 and the Aid flow from UN agencies (US$) in St. Lucia in 1987?
Keep it short and to the point. 4.40e+05. What is the difference between the Aid flow from UN agencies (US$) of Egypt, Arab Rep. in 1985 and the Aid flow from UN agencies (US$) of Lesotho in 1987?
Ensure brevity in your answer.  8.39e+06. What is the difference between the Aid flow from UN agencies (US$) in Egypt, Arab Rep. in 1985 and the Aid flow from UN agencies (US$) in St. Lucia in 1987?
Provide a succinct answer. 1.87e+07. What is the difference between the Aid flow from UN agencies (US$) in Lesotho in 1985 and the Aid flow from UN agencies (US$) in St. Lucia in 1987?
Provide a succinct answer. 9.89e+06. What is the difference between the Aid flow from UN agencies (US$) in European Union in 1985 and the Aid flow from UN agencies (US$) in Egypt, Arab Rep. in 1988?
Offer a very short reply. -1.26e+07. What is the difference between the Aid flow from UN agencies (US$) of European Union in 1985 and the Aid flow from UN agencies (US$) of Lesotho in 1988?
Provide a succinct answer. -3.21e+06. What is the difference between the Aid flow from UN agencies (US$) in European Union in 1985 and the Aid flow from UN agencies (US$) in St. Lucia in 1988?
Provide a succinct answer. -1.65e+06. What is the difference between the Aid flow from UN agencies (US$) in Egypt, Arab Rep. in 1985 and the Aid flow from UN agencies (US$) in Lesotho in 1988?
Give a very brief answer. 1.51e+07. What is the difference between the Aid flow from UN agencies (US$) of Egypt, Arab Rep. in 1985 and the Aid flow from UN agencies (US$) of St. Lucia in 1988?
Your answer should be compact. 1.66e+07. What is the difference between the Aid flow from UN agencies (US$) in Lesotho in 1985 and the Aid flow from UN agencies (US$) in St. Lucia in 1988?
Offer a very short reply. 7.80e+06. What is the difference between the Aid flow from UN agencies (US$) of European Union in 1986 and the Aid flow from UN agencies (US$) of Egypt, Arab Rep. in 1987?
Ensure brevity in your answer.  -1.39e+07. What is the difference between the Aid flow from UN agencies (US$) of European Union in 1986 and the Aid flow from UN agencies (US$) of Lesotho in 1987?
Keep it short and to the point. -9.00e+06. What is the difference between the Aid flow from UN agencies (US$) in European Union in 1986 and the Aid flow from UN agencies (US$) in St. Lucia in 1987?
Ensure brevity in your answer.  1.33e+06. What is the difference between the Aid flow from UN agencies (US$) in Egypt, Arab Rep. in 1986 and the Aid flow from UN agencies (US$) in Lesotho in 1987?
Make the answer very short. -3.33e+06. What is the difference between the Aid flow from UN agencies (US$) of Lesotho in 1986 and the Aid flow from UN agencies (US$) of St. Lucia in 1987?
Give a very brief answer. 7.79e+06. What is the difference between the Aid flow from UN agencies (US$) of European Union in 1986 and the Aid flow from UN agencies (US$) of Egypt, Arab Rep. in 1988?
Your answer should be compact. -1.17e+07. What is the difference between the Aid flow from UN agencies (US$) of European Union in 1986 and the Aid flow from UN agencies (US$) of Lesotho in 1988?
Your answer should be very brief. -2.32e+06. What is the difference between the Aid flow from UN agencies (US$) in European Union in 1986 and the Aid flow from UN agencies (US$) in St. Lucia in 1988?
Make the answer very short. -7.60e+05. What is the difference between the Aid flow from UN agencies (US$) in Egypt, Arab Rep. in 1986 and the Aid flow from UN agencies (US$) in Lesotho in 1988?
Make the answer very short. 3.35e+06. What is the difference between the Aid flow from UN agencies (US$) in Egypt, Arab Rep. in 1986 and the Aid flow from UN agencies (US$) in St. Lucia in 1988?
Provide a short and direct response. 4.91e+06. What is the difference between the Aid flow from UN agencies (US$) in Lesotho in 1986 and the Aid flow from UN agencies (US$) in St. Lucia in 1988?
Offer a very short reply. 5.70e+06. What is the difference between the Aid flow from UN agencies (US$) of European Union in 1987 and the Aid flow from UN agencies (US$) of Egypt, Arab Rep. in 1988?
Offer a terse response. -1.29e+07. What is the difference between the Aid flow from UN agencies (US$) of European Union in 1987 and the Aid flow from UN agencies (US$) of Lesotho in 1988?
Ensure brevity in your answer.  -3.47e+06. What is the difference between the Aid flow from UN agencies (US$) in European Union in 1987 and the Aid flow from UN agencies (US$) in St. Lucia in 1988?
Your answer should be compact. -1.91e+06. What is the difference between the Aid flow from UN agencies (US$) of Egypt, Arab Rep. in 1987 and the Aid flow from UN agencies (US$) of Lesotho in 1988?
Offer a very short reply. 1.16e+07. What is the difference between the Aid flow from UN agencies (US$) of Egypt, Arab Rep. in 1987 and the Aid flow from UN agencies (US$) of St. Lucia in 1988?
Keep it short and to the point. 1.32e+07. What is the difference between the Aid flow from UN agencies (US$) in Lesotho in 1987 and the Aid flow from UN agencies (US$) in St. Lucia in 1988?
Keep it short and to the point. 8.24e+06. What is the average Aid flow from UN agencies (US$) in European Union per year?
Provide a short and direct response. 1.33e+06. What is the average Aid flow from UN agencies (US$) in Egypt, Arab Rep. per year?
Provide a short and direct response. 2.24e+07. What is the average Aid flow from UN agencies (US$) in Lesotho per year?
Keep it short and to the point. 8.69e+06. What is the average Aid flow from UN agencies (US$) of St. Lucia per year?
Ensure brevity in your answer.  5.56e+05. In the year 1981, what is the difference between the Aid flow from UN agencies (US$) in European Union and Aid flow from UN agencies (US$) in Egypt, Arab Rep.?
Ensure brevity in your answer.  -3.01e+07. In the year 1981, what is the difference between the Aid flow from UN agencies (US$) of European Union and Aid flow from UN agencies (US$) of Lesotho?
Your answer should be compact. -1.27e+07. In the year 1981, what is the difference between the Aid flow from UN agencies (US$) of European Union and Aid flow from UN agencies (US$) of St. Lucia?
Your response must be concise. 1.19e+06. In the year 1981, what is the difference between the Aid flow from UN agencies (US$) in Egypt, Arab Rep. and Aid flow from UN agencies (US$) in Lesotho?
Your response must be concise. 1.74e+07. In the year 1981, what is the difference between the Aid flow from UN agencies (US$) of Egypt, Arab Rep. and Aid flow from UN agencies (US$) of St. Lucia?
Your answer should be very brief. 3.13e+07. In the year 1981, what is the difference between the Aid flow from UN agencies (US$) in Lesotho and Aid flow from UN agencies (US$) in St. Lucia?
Provide a succinct answer. 1.39e+07. In the year 1982, what is the difference between the Aid flow from UN agencies (US$) of European Union and Aid flow from UN agencies (US$) of Egypt, Arab Rep.?
Your answer should be compact. -3.91e+07. In the year 1982, what is the difference between the Aid flow from UN agencies (US$) of European Union and Aid flow from UN agencies (US$) of Lesotho?
Offer a very short reply. 1.05e+06. In the year 1982, what is the difference between the Aid flow from UN agencies (US$) in European Union and Aid flow from UN agencies (US$) in St. Lucia?
Offer a terse response. 4.14e+06. In the year 1982, what is the difference between the Aid flow from UN agencies (US$) in Egypt, Arab Rep. and Aid flow from UN agencies (US$) in Lesotho?
Offer a terse response. 4.01e+07. In the year 1982, what is the difference between the Aid flow from UN agencies (US$) of Egypt, Arab Rep. and Aid flow from UN agencies (US$) of St. Lucia?
Make the answer very short. 4.32e+07. In the year 1982, what is the difference between the Aid flow from UN agencies (US$) of Lesotho and Aid flow from UN agencies (US$) of St. Lucia?
Your answer should be compact. 3.09e+06. In the year 1983, what is the difference between the Aid flow from UN agencies (US$) in European Union and Aid flow from UN agencies (US$) in Egypt, Arab Rep.?
Offer a terse response. -3.69e+07. In the year 1983, what is the difference between the Aid flow from UN agencies (US$) in European Union and Aid flow from UN agencies (US$) in Lesotho?
Offer a very short reply. -9.39e+06. In the year 1983, what is the difference between the Aid flow from UN agencies (US$) in European Union and Aid flow from UN agencies (US$) in St. Lucia?
Your answer should be very brief. 9.80e+05. In the year 1983, what is the difference between the Aid flow from UN agencies (US$) of Egypt, Arab Rep. and Aid flow from UN agencies (US$) of Lesotho?
Your answer should be compact. 2.76e+07. In the year 1983, what is the difference between the Aid flow from UN agencies (US$) in Egypt, Arab Rep. and Aid flow from UN agencies (US$) in St. Lucia?
Offer a terse response. 3.79e+07. In the year 1983, what is the difference between the Aid flow from UN agencies (US$) of Lesotho and Aid flow from UN agencies (US$) of St. Lucia?
Your answer should be very brief. 1.04e+07. In the year 1984, what is the difference between the Aid flow from UN agencies (US$) in European Union and Aid flow from UN agencies (US$) in Egypt, Arab Rep.?
Ensure brevity in your answer.  -1.04e+07. In the year 1984, what is the difference between the Aid flow from UN agencies (US$) of European Union and Aid flow from UN agencies (US$) of Lesotho?
Your answer should be compact. -8.10e+06. In the year 1984, what is the difference between the Aid flow from UN agencies (US$) of European Union and Aid flow from UN agencies (US$) of St. Lucia?
Offer a very short reply. -1.20e+05. In the year 1984, what is the difference between the Aid flow from UN agencies (US$) in Egypt, Arab Rep. and Aid flow from UN agencies (US$) in Lesotho?
Offer a very short reply. 2.32e+06. In the year 1984, what is the difference between the Aid flow from UN agencies (US$) in Egypt, Arab Rep. and Aid flow from UN agencies (US$) in St. Lucia?
Keep it short and to the point. 1.03e+07. In the year 1984, what is the difference between the Aid flow from UN agencies (US$) of Lesotho and Aid flow from UN agencies (US$) of St. Lucia?
Offer a very short reply. 7.98e+06. In the year 1985, what is the difference between the Aid flow from UN agencies (US$) of European Union and Aid flow from UN agencies (US$) of Egypt, Arab Rep.?
Ensure brevity in your answer.  -1.83e+07. In the year 1985, what is the difference between the Aid flow from UN agencies (US$) of European Union and Aid flow from UN agencies (US$) of Lesotho?
Offer a terse response. -9.45e+06. In the year 1985, what is the difference between the Aid flow from UN agencies (US$) of Egypt, Arab Rep. and Aid flow from UN agencies (US$) of Lesotho?
Your answer should be very brief. 8.83e+06. In the year 1985, what is the difference between the Aid flow from UN agencies (US$) in Egypt, Arab Rep. and Aid flow from UN agencies (US$) in St. Lucia?
Provide a short and direct response. 1.89e+07. In the year 1985, what is the difference between the Aid flow from UN agencies (US$) of Lesotho and Aid flow from UN agencies (US$) of St. Lucia?
Your response must be concise. 1.01e+07. In the year 1986, what is the difference between the Aid flow from UN agencies (US$) in European Union and Aid flow from UN agencies (US$) in Egypt, Arab Rep.?
Your answer should be compact. -5.67e+06. In the year 1986, what is the difference between the Aid flow from UN agencies (US$) of European Union and Aid flow from UN agencies (US$) of Lesotho?
Offer a terse response. -6.46e+06. In the year 1986, what is the difference between the Aid flow from UN agencies (US$) in European Union and Aid flow from UN agencies (US$) in St. Lucia?
Keep it short and to the point. 1.31e+06. In the year 1986, what is the difference between the Aid flow from UN agencies (US$) in Egypt, Arab Rep. and Aid flow from UN agencies (US$) in Lesotho?
Provide a short and direct response. -7.90e+05. In the year 1986, what is the difference between the Aid flow from UN agencies (US$) of Egypt, Arab Rep. and Aid flow from UN agencies (US$) of St. Lucia?
Make the answer very short. 6.98e+06. In the year 1986, what is the difference between the Aid flow from UN agencies (US$) in Lesotho and Aid flow from UN agencies (US$) in St. Lucia?
Your response must be concise. 7.77e+06. In the year 1987, what is the difference between the Aid flow from UN agencies (US$) in European Union and Aid flow from UN agencies (US$) in Egypt, Arab Rep.?
Ensure brevity in your answer.  -1.51e+07. In the year 1987, what is the difference between the Aid flow from UN agencies (US$) in European Union and Aid flow from UN agencies (US$) in Lesotho?
Your answer should be very brief. -1.02e+07. In the year 1987, what is the difference between the Aid flow from UN agencies (US$) in European Union and Aid flow from UN agencies (US$) in St. Lucia?
Your answer should be very brief. 1.80e+05. In the year 1987, what is the difference between the Aid flow from UN agencies (US$) in Egypt, Arab Rep. and Aid flow from UN agencies (US$) in Lesotho?
Offer a very short reply. 4.92e+06. In the year 1987, what is the difference between the Aid flow from UN agencies (US$) of Egypt, Arab Rep. and Aid flow from UN agencies (US$) of St. Lucia?
Your answer should be very brief. 1.52e+07. In the year 1987, what is the difference between the Aid flow from UN agencies (US$) in Lesotho and Aid flow from UN agencies (US$) in St. Lucia?
Provide a short and direct response. 1.03e+07. In the year 1988, what is the difference between the Aid flow from UN agencies (US$) in European Union and Aid flow from UN agencies (US$) in Egypt, Arab Rep.?
Your response must be concise. -1.30e+07. In the year 1988, what is the difference between the Aid flow from UN agencies (US$) in European Union and Aid flow from UN agencies (US$) in Lesotho?
Offer a very short reply. -3.66e+06. In the year 1988, what is the difference between the Aid flow from UN agencies (US$) in European Union and Aid flow from UN agencies (US$) in St. Lucia?
Provide a short and direct response. -2.10e+06. In the year 1988, what is the difference between the Aid flow from UN agencies (US$) in Egypt, Arab Rep. and Aid flow from UN agencies (US$) in Lesotho?
Make the answer very short. 9.39e+06. In the year 1988, what is the difference between the Aid flow from UN agencies (US$) of Egypt, Arab Rep. and Aid flow from UN agencies (US$) of St. Lucia?
Your answer should be very brief. 1.10e+07. In the year 1988, what is the difference between the Aid flow from UN agencies (US$) of Lesotho and Aid flow from UN agencies (US$) of St. Lucia?
Provide a succinct answer. 1.56e+06. What is the ratio of the Aid flow from UN agencies (US$) of European Union in 1981 to that in 1982?
Give a very brief answer. 0.34. What is the ratio of the Aid flow from UN agencies (US$) of Egypt, Arab Rep. in 1981 to that in 1982?
Your response must be concise. 0.73. What is the ratio of the Aid flow from UN agencies (US$) of Lesotho in 1981 to that in 1982?
Ensure brevity in your answer.  4.15. What is the ratio of the Aid flow from UN agencies (US$) in European Union in 1981 to that in 1983?
Make the answer very short. 1.23. What is the ratio of the Aid flow from UN agencies (US$) in Egypt, Arab Rep. in 1981 to that in 1983?
Keep it short and to the point. 0.83. What is the ratio of the Aid flow from UN agencies (US$) in Lesotho in 1981 to that in 1983?
Provide a succinct answer. 1.34. What is the ratio of the Aid flow from UN agencies (US$) of St. Lucia in 1981 to that in 1983?
Provide a short and direct response. 1.3. What is the ratio of the Aid flow from UN agencies (US$) in Egypt, Arab Rep. in 1981 to that in 1984?
Offer a very short reply. 2.98. What is the ratio of the Aid flow from UN agencies (US$) in Lesotho in 1981 to that in 1984?
Your answer should be compact. 1.71. What is the ratio of the Aid flow from UN agencies (US$) in St. Lucia in 1981 to that in 1984?
Provide a succinct answer. 1.03. What is the ratio of the Aid flow from UN agencies (US$) of European Union in 1981 to that in 1985?
Your answer should be very brief. 2.08. What is the ratio of the Aid flow from UN agencies (US$) in Egypt, Arab Rep. in 1981 to that in 1985?
Give a very brief answer. 1.67. What is the ratio of the Aid flow from UN agencies (US$) in Lesotho in 1981 to that in 1985?
Ensure brevity in your answer.  1.4. What is the ratio of the Aid flow from UN agencies (US$) in St. Lucia in 1981 to that in 1985?
Provide a succinct answer. 2.69. What is the ratio of the Aid flow from UN agencies (US$) in European Union in 1981 to that in 1986?
Your answer should be compact. 0.94. What is the ratio of the Aid flow from UN agencies (US$) in Egypt, Arab Rep. in 1981 to that in 1986?
Your answer should be very brief. 4.34. What is the ratio of the Aid flow from UN agencies (US$) in Lesotho in 1981 to that in 1986?
Your answer should be very brief. 1.76. What is the ratio of the Aid flow from UN agencies (US$) of St. Lucia in 1981 to that in 1986?
Offer a very short reply. 1.09. What is the ratio of the Aid flow from UN agencies (US$) of European Union in 1981 to that in 1987?
Ensure brevity in your answer.  3.21. What is the ratio of the Aid flow from UN agencies (US$) of Egypt, Arab Rep. in 1981 to that in 1987?
Offer a terse response. 2.04. What is the ratio of the Aid flow from UN agencies (US$) of Lesotho in 1981 to that in 1987?
Make the answer very short. 1.34. What is the ratio of the Aid flow from UN agencies (US$) of European Union in 1981 to that in 1988?
Your answer should be compact. 5.31. What is the ratio of the Aid flow from UN agencies (US$) of Egypt, Arab Rep. in 1981 to that in 1988?
Provide a succinct answer. 2.37. What is the ratio of the Aid flow from UN agencies (US$) of Lesotho in 1981 to that in 1988?
Your answer should be very brief. 3.61. What is the ratio of the Aid flow from UN agencies (US$) of St. Lucia in 1981 to that in 1988?
Offer a very short reply. 0.15. What is the ratio of the Aid flow from UN agencies (US$) of European Union in 1982 to that in 1983?
Provide a short and direct response. 3.59. What is the ratio of the Aid flow from UN agencies (US$) in Egypt, Arab Rep. in 1982 to that in 1983?
Provide a succinct answer. 1.14. What is the ratio of the Aid flow from UN agencies (US$) of Lesotho in 1982 to that in 1983?
Your answer should be very brief. 0.32. What is the ratio of the Aid flow from UN agencies (US$) in St. Lucia in 1982 to that in 1983?
Offer a very short reply. 1.3. What is the ratio of the Aid flow from UN agencies (US$) in European Union in 1982 to that in 1984?
Provide a succinct answer. 20.41. What is the ratio of the Aid flow from UN agencies (US$) in Egypt, Arab Rep. in 1982 to that in 1984?
Your answer should be very brief. 4.09. What is the ratio of the Aid flow from UN agencies (US$) of Lesotho in 1982 to that in 1984?
Your answer should be very brief. 0.41. What is the ratio of the Aid flow from UN agencies (US$) in St. Lucia in 1982 to that in 1984?
Your answer should be very brief. 1.03. What is the ratio of the Aid flow from UN agencies (US$) of European Union in 1982 to that in 1985?
Your answer should be very brief. 6.07. What is the ratio of the Aid flow from UN agencies (US$) in Egypt, Arab Rep. in 1982 to that in 1985?
Provide a succinct answer. 2.29. What is the ratio of the Aid flow from UN agencies (US$) in Lesotho in 1982 to that in 1985?
Your response must be concise. 0.34. What is the ratio of the Aid flow from UN agencies (US$) of St. Lucia in 1982 to that in 1985?
Give a very brief answer. 2.69. What is the ratio of the Aid flow from UN agencies (US$) of European Union in 1982 to that in 1986?
Your answer should be compact. 2.75. What is the ratio of the Aid flow from UN agencies (US$) of Egypt, Arab Rep. in 1982 to that in 1986?
Give a very brief answer. 5.97. What is the ratio of the Aid flow from UN agencies (US$) in Lesotho in 1982 to that in 1986?
Provide a short and direct response. 0.43. What is the ratio of the Aid flow from UN agencies (US$) in St. Lucia in 1982 to that in 1986?
Ensure brevity in your answer.  1.09. What is the ratio of the Aid flow from UN agencies (US$) in European Union in 1982 to that in 1987?
Keep it short and to the point. 9.35. What is the ratio of the Aid flow from UN agencies (US$) of Egypt, Arab Rep. in 1982 to that in 1987?
Your answer should be very brief. 2.8. What is the ratio of the Aid flow from UN agencies (US$) of Lesotho in 1982 to that in 1987?
Your response must be concise. 0.32. What is the ratio of the Aid flow from UN agencies (US$) in St. Lucia in 1982 to that in 1987?
Keep it short and to the point. 1.17. What is the ratio of the Aid flow from UN agencies (US$) in European Union in 1982 to that in 1988?
Ensure brevity in your answer.  15.48. What is the ratio of the Aid flow from UN agencies (US$) of Egypt, Arab Rep. in 1982 to that in 1988?
Offer a very short reply. 3.27. What is the ratio of the Aid flow from UN agencies (US$) in Lesotho in 1982 to that in 1988?
Your answer should be compact. 0.87. What is the ratio of the Aid flow from UN agencies (US$) of St. Lucia in 1982 to that in 1988?
Ensure brevity in your answer.  0.15. What is the ratio of the Aid flow from UN agencies (US$) of European Union in 1983 to that in 1984?
Provide a short and direct response. 5.68. What is the ratio of the Aid flow from UN agencies (US$) in Egypt, Arab Rep. in 1983 to that in 1984?
Provide a short and direct response. 3.59. What is the ratio of the Aid flow from UN agencies (US$) in Lesotho in 1983 to that in 1984?
Give a very brief answer. 1.28. What is the ratio of the Aid flow from UN agencies (US$) in St. Lucia in 1983 to that in 1984?
Offer a very short reply. 0.79. What is the ratio of the Aid flow from UN agencies (US$) of European Union in 1983 to that in 1985?
Give a very brief answer. 1.69. What is the ratio of the Aid flow from UN agencies (US$) of Egypt, Arab Rep. in 1983 to that in 1985?
Keep it short and to the point. 2.01. What is the ratio of the Aid flow from UN agencies (US$) of Lesotho in 1983 to that in 1985?
Provide a short and direct response. 1.04. What is the ratio of the Aid flow from UN agencies (US$) in St. Lucia in 1983 to that in 1985?
Keep it short and to the point. 2.08. What is the ratio of the Aid flow from UN agencies (US$) in European Union in 1983 to that in 1986?
Give a very brief answer. 0.77. What is the ratio of the Aid flow from UN agencies (US$) of Egypt, Arab Rep. in 1983 to that in 1986?
Make the answer very short. 5.23. What is the ratio of the Aid flow from UN agencies (US$) in Lesotho in 1983 to that in 1986?
Your response must be concise. 1.32. What is the ratio of the Aid flow from UN agencies (US$) of St. Lucia in 1983 to that in 1986?
Provide a short and direct response. 0.84. What is the ratio of the Aid flow from UN agencies (US$) in European Union in 1983 to that in 1987?
Offer a very short reply. 2.6. What is the ratio of the Aid flow from UN agencies (US$) in Egypt, Arab Rep. in 1983 to that in 1987?
Provide a succinct answer. 2.46. What is the ratio of the Aid flow from UN agencies (US$) in Lesotho in 1983 to that in 1987?
Your answer should be compact. 1. What is the ratio of the Aid flow from UN agencies (US$) of St. Lucia in 1983 to that in 1987?
Your answer should be compact. 0.9. What is the ratio of the Aid flow from UN agencies (US$) of European Union in 1983 to that in 1988?
Offer a terse response. 4.31. What is the ratio of the Aid flow from UN agencies (US$) in Egypt, Arab Rep. in 1983 to that in 1988?
Keep it short and to the point. 2.86. What is the ratio of the Aid flow from UN agencies (US$) in Lesotho in 1983 to that in 1988?
Ensure brevity in your answer.  2.69. What is the ratio of the Aid flow from UN agencies (US$) of St. Lucia in 1983 to that in 1988?
Give a very brief answer. 0.11. What is the ratio of the Aid flow from UN agencies (US$) of European Union in 1984 to that in 1985?
Give a very brief answer. 0.3. What is the ratio of the Aid flow from UN agencies (US$) in Egypt, Arab Rep. in 1984 to that in 1985?
Offer a terse response. 0.56. What is the ratio of the Aid flow from UN agencies (US$) of Lesotho in 1984 to that in 1985?
Ensure brevity in your answer.  0.82. What is the ratio of the Aid flow from UN agencies (US$) of St. Lucia in 1984 to that in 1985?
Offer a terse response. 2.62. What is the ratio of the Aid flow from UN agencies (US$) in European Union in 1984 to that in 1986?
Your response must be concise. 0.14. What is the ratio of the Aid flow from UN agencies (US$) of Egypt, Arab Rep. in 1984 to that in 1986?
Give a very brief answer. 1.46. What is the ratio of the Aid flow from UN agencies (US$) of Lesotho in 1984 to that in 1986?
Offer a terse response. 1.03. What is the ratio of the Aid flow from UN agencies (US$) of St. Lucia in 1984 to that in 1986?
Provide a succinct answer. 1.06. What is the ratio of the Aid flow from UN agencies (US$) in European Union in 1984 to that in 1987?
Make the answer very short. 0.46. What is the ratio of the Aid flow from UN agencies (US$) in Egypt, Arab Rep. in 1984 to that in 1987?
Ensure brevity in your answer.  0.68. What is the ratio of the Aid flow from UN agencies (US$) of Lesotho in 1984 to that in 1987?
Your answer should be compact. 0.78. What is the ratio of the Aid flow from UN agencies (US$) of St. Lucia in 1984 to that in 1987?
Provide a succinct answer. 1.13. What is the ratio of the Aid flow from UN agencies (US$) in European Union in 1984 to that in 1988?
Provide a succinct answer. 0.76. What is the ratio of the Aid flow from UN agencies (US$) of Egypt, Arab Rep. in 1984 to that in 1988?
Ensure brevity in your answer.  0.8. What is the ratio of the Aid flow from UN agencies (US$) in Lesotho in 1984 to that in 1988?
Provide a short and direct response. 2.11. What is the ratio of the Aid flow from UN agencies (US$) in St. Lucia in 1984 to that in 1988?
Keep it short and to the point. 0.14. What is the ratio of the Aid flow from UN agencies (US$) in European Union in 1985 to that in 1986?
Your response must be concise. 0.45. What is the ratio of the Aid flow from UN agencies (US$) in Egypt, Arab Rep. in 1985 to that in 1986?
Offer a terse response. 2.61. What is the ratio of the Aid flow from UN agencies (US$) in Lesotho in 1985 to that in 1986?
Make the answer very short. 1.26. What is the ratio of the Aid flow from UN agencies (US$) of St. Lucia in 1985 to that in 1986?
Your answer should be compact. 0.41. What is the ratio of the Aid flow from UN agencies (US$) in European Union in 1985 to that in 1987?
Your answer should be compact. 1.54. What is the ratio of the Aid flow from UN agencies (US$) of Egypt, Arab Rep. in 1985 to that in 1987?
Provide a short and direct response. 1.22. What is the ratio of the Aid flow from UN agencies (US$) of Lesotho in 1985 to that in 1987?
Ensure brevity in your answer.  0.96. What is the ratio of the Aid flow from UN agencies (US$) of St. Lucia in 1985 to that in 1987?
Your answer should be compact. 0.43. What is the ratio of the Aid flow from UN agencies (US$) of European Union in 1985 to that in 1988?
Ensure brevity in your answer.  2.55. What is the ratio of the Aid flow from UN agencies (US$) of Egypt, Arab Rep. in 1985 to that in 1988?
Your answer should be compact. 1.43. What is the ratio of the Aid flow from UN agencies (US$) in Lesotho in 1985 to that in 1988?
Provide a short and direct response. 2.58. What is the ratio of the Aid flow from UN agencies (US$) in St. Lucia in 1985 to that in 1988?
Offer a terse response. 0.05. What is the ratio of the Aid flow from UN agencies (US$) in European Union in 1986 to that in 1987?
Offer a terse response. 3.4. What is the ratio of the Aid flow from UN agencies (US$) in Egypt, Arab Rep. in 1986 to that in 1987?
Make the answer very short. 0.47. What is the ratio of the Aid flow from UN agencies (US$) in Lesotho in 1986 to that in 1987?
Ensure brevity in your answer.  0.76. What is the ratio of the Aid flow from UN agencies (US$) of St. Lucia in 1986 to that in 1987?
Your answer should be compact. 1.07. What is the ratio of the Aid flow from UN agencies (US$) of European Union in 1986 to that in 1988?
Provide a short and direct response. 5.62. What is the ratio of the Aid flow from UN agencies (US$) of Egypt, Arab Rep. in 1986 to that in 1988?
Ensure brevity in your answer.  0.55. What is the ratio of the Aid flow from UN agencies (US$) of Lesotho in 1986 to that in 1988?
Offer a very short reply. 2.05. What is the ratio of the Aid flow from UN agencies (US$) of St. Lucia in 1986 to that in 1988?
Make the answer very short. 0.13. What is the ratio of the Aid flow from UN agencies (US$) of European Union in 1987 to that in 1988?
Your answer should be very brief. 1.66. What is the ratio of the Aid flow from UN agencies (US$) in Egypt, Arab Rep. in 1987 to that in 1988?
Give a very brief answer. 1.17. What is the ratio of the Aid flow from UN agencies (US$) of Lesotho in 1987 to that in 1988?
Provide a short and direct response. 2.69. What is the ratio of the Aid flow from UN agencies (US$) of St. Lucia in 1987 to that in 1988?
Provide a short and direct response. 0.13. What is the difference between the highest and the second highest Aid flow from UN agencies (US$) of European Union?
Ensure brevity in your answer.  2.86e+06. What is the difference between the highest and the second highest Aid flow from UN agencies (US$) of Egypt, Arab Rep.?
Your answer should be compact. 5.38e+06. What is the difference between the highest and the second highest Aid flow from UN agencies (US$) in Lesotho?
Offer a very short reply. 3.62e+06. What is the difference between the highest and the second highest Aid flow from UN agencies (US$) of St. Lucia?
Provide a short and direct response. 2.04e+06. What is the difference between the highest and the lowest Aid flow from UN agencies (US$) in European Union?
Your answer should be very brief. 4.27e+06. What is the difference between the highest and the lowest Aid flow from UN agencies (US$) of Egypt, Arab Rep.?
Give a very brief answer. 3.63e+07. What is the difference between the highest and the lowest Aid flow from UN agencies (US$) of Lesotho?
Offer a very short reply. 1.08e+07. What is the difference between the highest and the lowest Aid flow from UN agencies (US$) of St. Lucia?
Provide a short and direct response. 2.26e+06. 